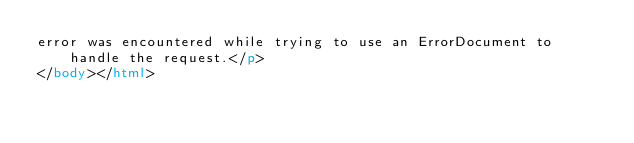<code> <loc_0><loc_0><loc_500><loc_500><_HTML_>error was encountered while trying to use an ErrorDocument to handle the request.</p>
</body></html>
</code> 